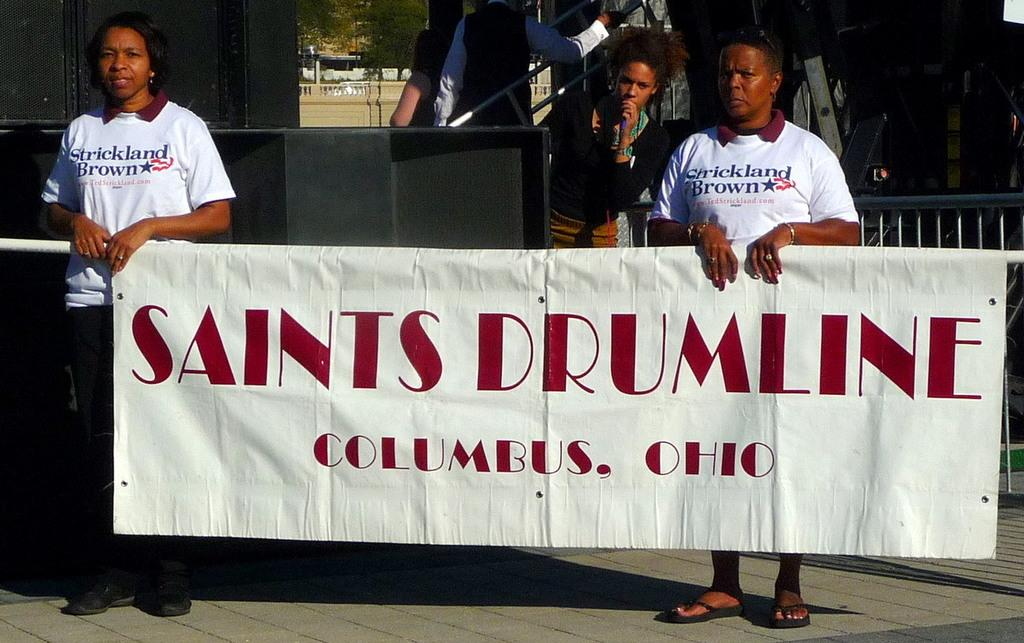<image>
Offer a succinct explanation of the picture presented. Two people in white shirts are holding a Saints Drumline banner. 